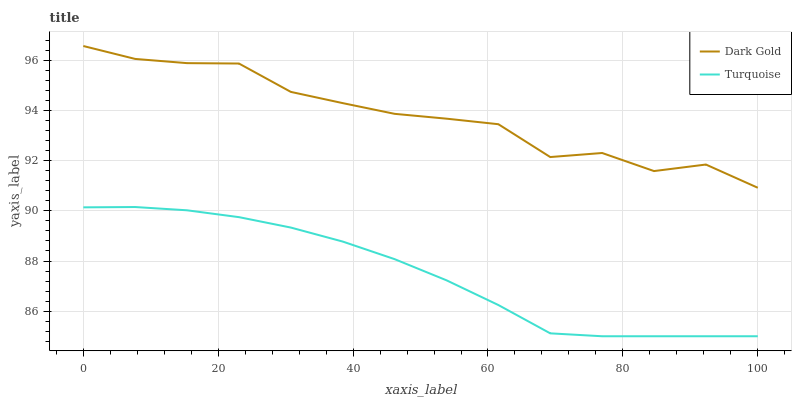Does Turquoise have the minimum area under the curve?
Answer yes or no. Yes. Does Dark Gold have the maximum area under the curve?
Answer yes or no. Yes. Does Dark Gold have the minimum area under the curve?
Answer yes or no. No. Is Turquoise the smoothest?
Answer yes or no. Yes. Is Dark Gold the roughest?
Answer yes or no. Yes. Is Dark Gold the smoothest?
Answer yes or no. No. Does Turquoise have the lowest value?
Answer yes or no. Yes. Does Dark Gold have the lowest value?
Answer yes or no. No. Does Dark Gold have the highest value?
Answer yes or no. Yes. Is Turquoise less than Dark Gold?
Answer yes or no. Yes. Is Dark Gold greater than Turquoise?
Answer yes or no. Yes. Does Turquoise intersect Dark Gold?
Answer yes or no. No. 